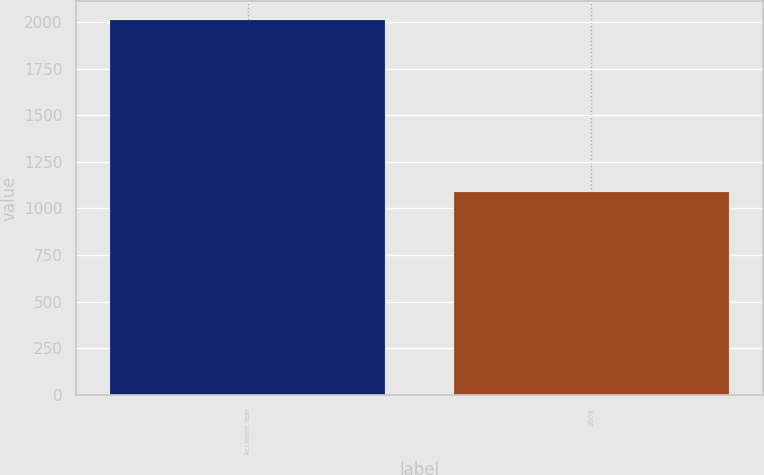Convert chart to OTSL. <chart><loc_0><loc_0><loc_500><loc_500><bar_chart><fcel>Accident Year<fcel>2008<nl><fcel>2013<fcel>1089<nl></chart> 